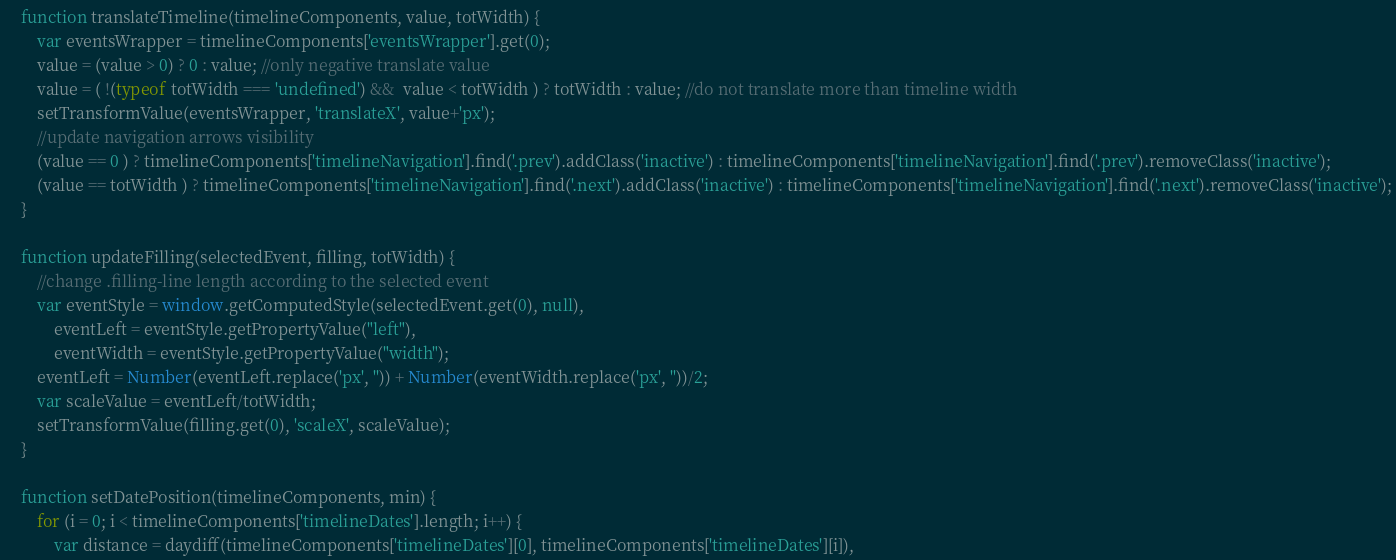Convert code to text. <code><loc_0><loc_0><loc_500><loc_500><_JavaScript_>	function translateTimeline(timelineComponents, value, totWidth) {
		var eventsWrapper = timelineComponents['eventsWrapper'].get(0);
		value = (value > 0) ? 0 : value; //only negative translate value
		value = ( !(typeof totWidth === 'undefined') &&  value < totWidth ) ? totWidth : value; //do not translate more than timeline width
		setTransformValue(eventsWrapper, 'translateX', value+'px');
		//update navigation arrows visibility
		(value == 0 ) ? timelineComponents['timelineNavigation'].find('.prev').addClass('inactive') : timelineComponents['timelineNavigation'].find('.prev').removeClass('inactive');
		(value == totWidth ) ? timelineComponents['timelineNavigation'].find('.next').addClass('inactive') : timelineComponents['timelineNavigation'].find('.next').removeClass('inactive');
	}

	function updateFilling(selectedEvent, filling, totWidth) {
		//change .filling-line length according to the selected event
		var eventStyle = window.getComputedStyle(selectedEvent.get(0), null),
			eventLeft = eventStyle.getPropertyValue("left"),
			eventWidth = eventStyle.getPropertyValue("width");
		eventLeft = Number(eventLeft.replace('px', '')) + Number(eventWidth.replace('px', ''))/2;
		var scaleValue = eventLeft/totWidth;
		setTransformValue(filling.get(0), 'scaleX', scaleValue);
	}

	function setDatePosition(timelineComponents, min) {
		for (i = 0; i < timelineComponents['timelineDates'].length; i++) { 
		    var distance = daydiff(timelineComponents['timelineDates'][0], timelineComponents['timelineDates'][i]),</code> 